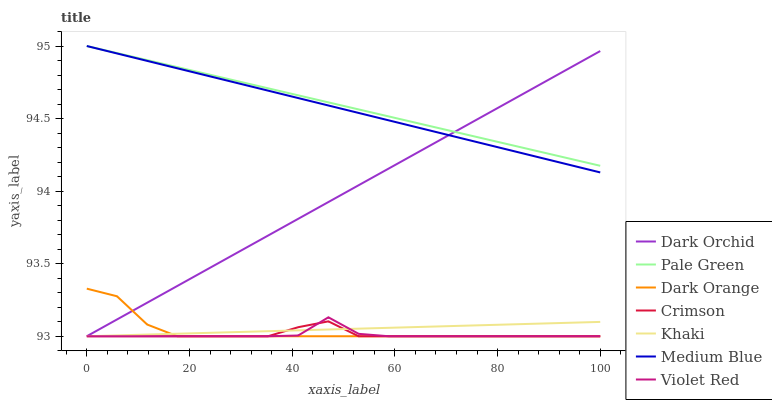Does Violet Red have the minimum area under the curve?
Answer yes or no. Yes. Does Pale Green have the maximum area under the curve?
Answer yes or no. Yes. Does Khaki have the minimum area under the curve?
Answer yes or no. No. Does Khaki have the maximum area under the curve?
Answer yes or no. No. Is Pale Green the smoothest?
Answer yes or no. Yes. Is Violet Red the roughest?
Answer yes or no. Yes. Is Khaki the smoothest?
Answer yes or no. No. Is Khaki the roughest?
Answer yes or no. No. Does Medium Blue have the lowest value?
Answer yes or no. No. Does Violet Red have the highest value?
Answer yes or no. No. Is Khaki less than Pale Green?
Answer yes or no. Yes. Is Medium Blue greater than Khaki?
Answer yes or no. Yes. Does Khaki intersect Pale Green?
Answer yes or no. No. 